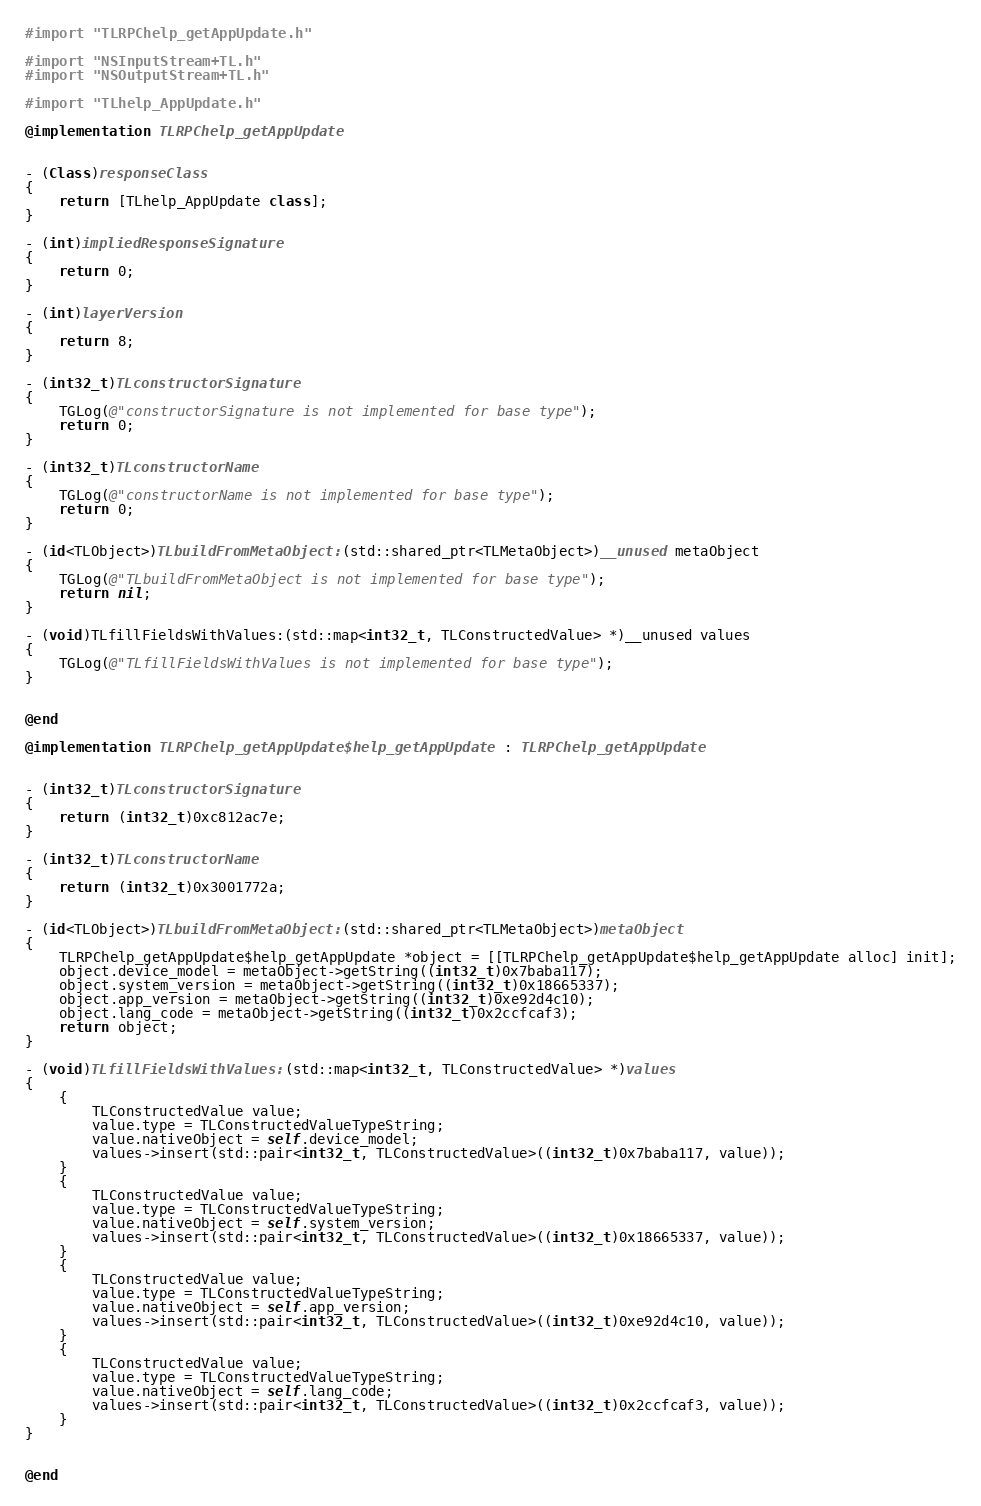Convert code to text. <code><loc_0><loc_0><loc_500><loc_500><_ObjectiveC_>#import "TLRPChelp_getAppUpdate.h"

#import "NSInputStream+TL.h"
#import "NSOutputStream+TL.h"

#import "TLhelp_AppUpdate.h"

@implementation TLRPChelp_getAppUpdate


- (Class)responseClass
{
    return [TLhelp_AppUpdate class];
}

- (int)impliedResponseSignature
{
    return 0;
}

- (int)layerVersion
{
    return 8;
}

- (int32_t)TLconstructorSignature
{
    TGLog(@"constructorSignature is not implemented for base type");
    return 0;
}

- (int32_t)TLconstructorName
{
    TGLog(@"constructorName is not implemented for base type");
    return 0;
}

- (id<TLObject>)TLbuildFromMetaObject:(std::shared_ptr<TLMetaObject>)__unused metaObject
{
    TGLog(@"TLbuildFromMetaObject is not implemented for base type");
    return nil;
}

- (void)TLfillFieldsWithValues:(std::map<int32_t, TLConstructedValue> *)__unused values
{
    TGLog(@"TLfillFieldsWithValues is not implemented for base type");
}


@end

@implementation TLRPChelp_getAppUpdate$help_getAppUpdate : TLRPChelp_getAppUpdate


- (int32_t)TLconstructorSignature
{
    return (int32_t)0xc812ac7e;
}

- (int32_t)TLconstructorName
{
    return (int32_t)0x3001772a;
}

- (id<TLObject>)TLbuildFromMetaObject:(std::shared_ptr<TLMetaObject>)metaObject
{
    TLRPChelp_getAppUpdate$help_getAppUpdate *object = [[TLRPChelp_getAppUpdate$help_getAppUpdate alloc] init];
    object.device_model = metaObject->getString((int32_t)0x7baba117);
    object.system_version = metaObject->getString((int32_t)0x18665337);
    object.app_version = metaObject->getString((int32_t)0xe92d4c10);
    object.lang_code = metaObject->getString((int32_t)0x2ccfcaf3);
    return object;
}

- (void)TLfillFieldsWithValues:(std::map<int32_t, TLConstructedValue> *)values
{
    {
        TLConstructedValue value;
        value.type = TLConstructedValueTypeString;
        value.nativeObject = self.device_model;
        values->insert(std::pair<int32_t, TLConstructedValue>((int32_t)0x7baba117, value));
    }
    {
        TLConstructedValue value;
        value.type = TLConstructedValueTypeString;
        value.nativeObject = self.system_version;
        values->insert(std::pair<int32_t, TLConstructedValue>((int32_t)0x18665337, value));
    }
    {
        TLConstructedValue value;
        value.type = TLConstructedValueTypeString;
        value.nativeObject = self.app_version;
        values->insert(std::pair<int32_t, TLConstructedValue>((int32_t)0xe92d4c10, value));
    }
    {
        TLConstructedValue value;
        value.type = TLConstructedValueTypeString;
        value.nativeObject = self.lang_code;
        values->insert(std::pair<int32_t, TLConstructedValue>((int32_t)0x2ccfcaf3, value));
    }
}


@end

</code> 